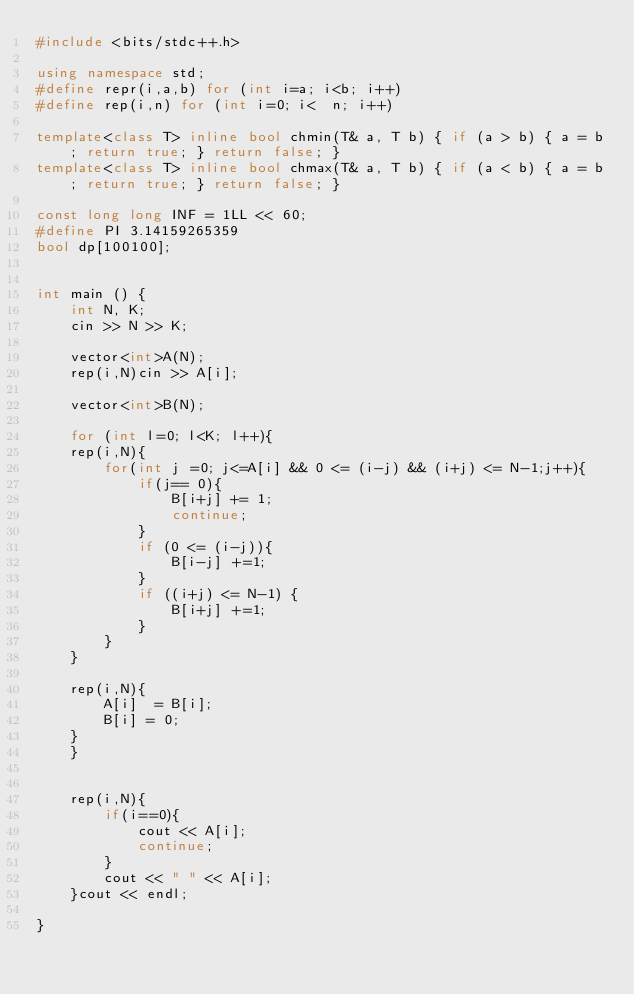Convert code to text. <code><loc_0><loc_0><loc_500><loc_500><_C++_>#include <bits/stdc++.h>
 
using namespace std;
#define repr(i,a,b) for (int i=a; i<b; i++)
#define rep(i,n) for (int i=0; i<  n; i++)
 
template<class T> inline bool chmin(T& a, T b) { if (a > b) { a = b; return true; } return false; }
template<class T> inline bool chmax(T& a, T b) { if (a < b) { a = b; return true; } return false; }
 
const long long INF = 1LL << 60;
#define PI 3.14159265359 
bool dp[100100];
 
 
int main () {
    int N, K;
    cin >> N >> K;

    vector<int>A(N);
    rep(i,N)cin >> A[i];

    vector<int>B(N);

    for (int l=0; l<K; l++){
    rep(i,N){
        for(int j =0; j<=A[i] && 0 <= (i-j) && (i+j) <= N-1;j++){
            if(j== 0){
                B[i+j] += 1;
                continue;
            }
            if (0 <= (i-j)){
                B[i-j] +=1;
            }
            if ((i+j) <= N-1) {
                B[i+j] +=1;
            }
        }
    }

    rep(i,N){
        A[i]  = B[i];
        B[i] = 0;
    }
    }


    rep(i,N){
        if(i==0){
            cout << A[i];
            continue;
        }
        cout << " " << A[i];
    }cout << endl;

}</code> 